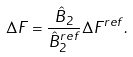<formula> <loc_0><loc_0><loc_500><loc_500>\Delta F = \frac { \hat { B } _ { 2 } } { \hat { B } _ { 2 } ^ { r e f } } \Delta F ^ { r e f } .</formula> 